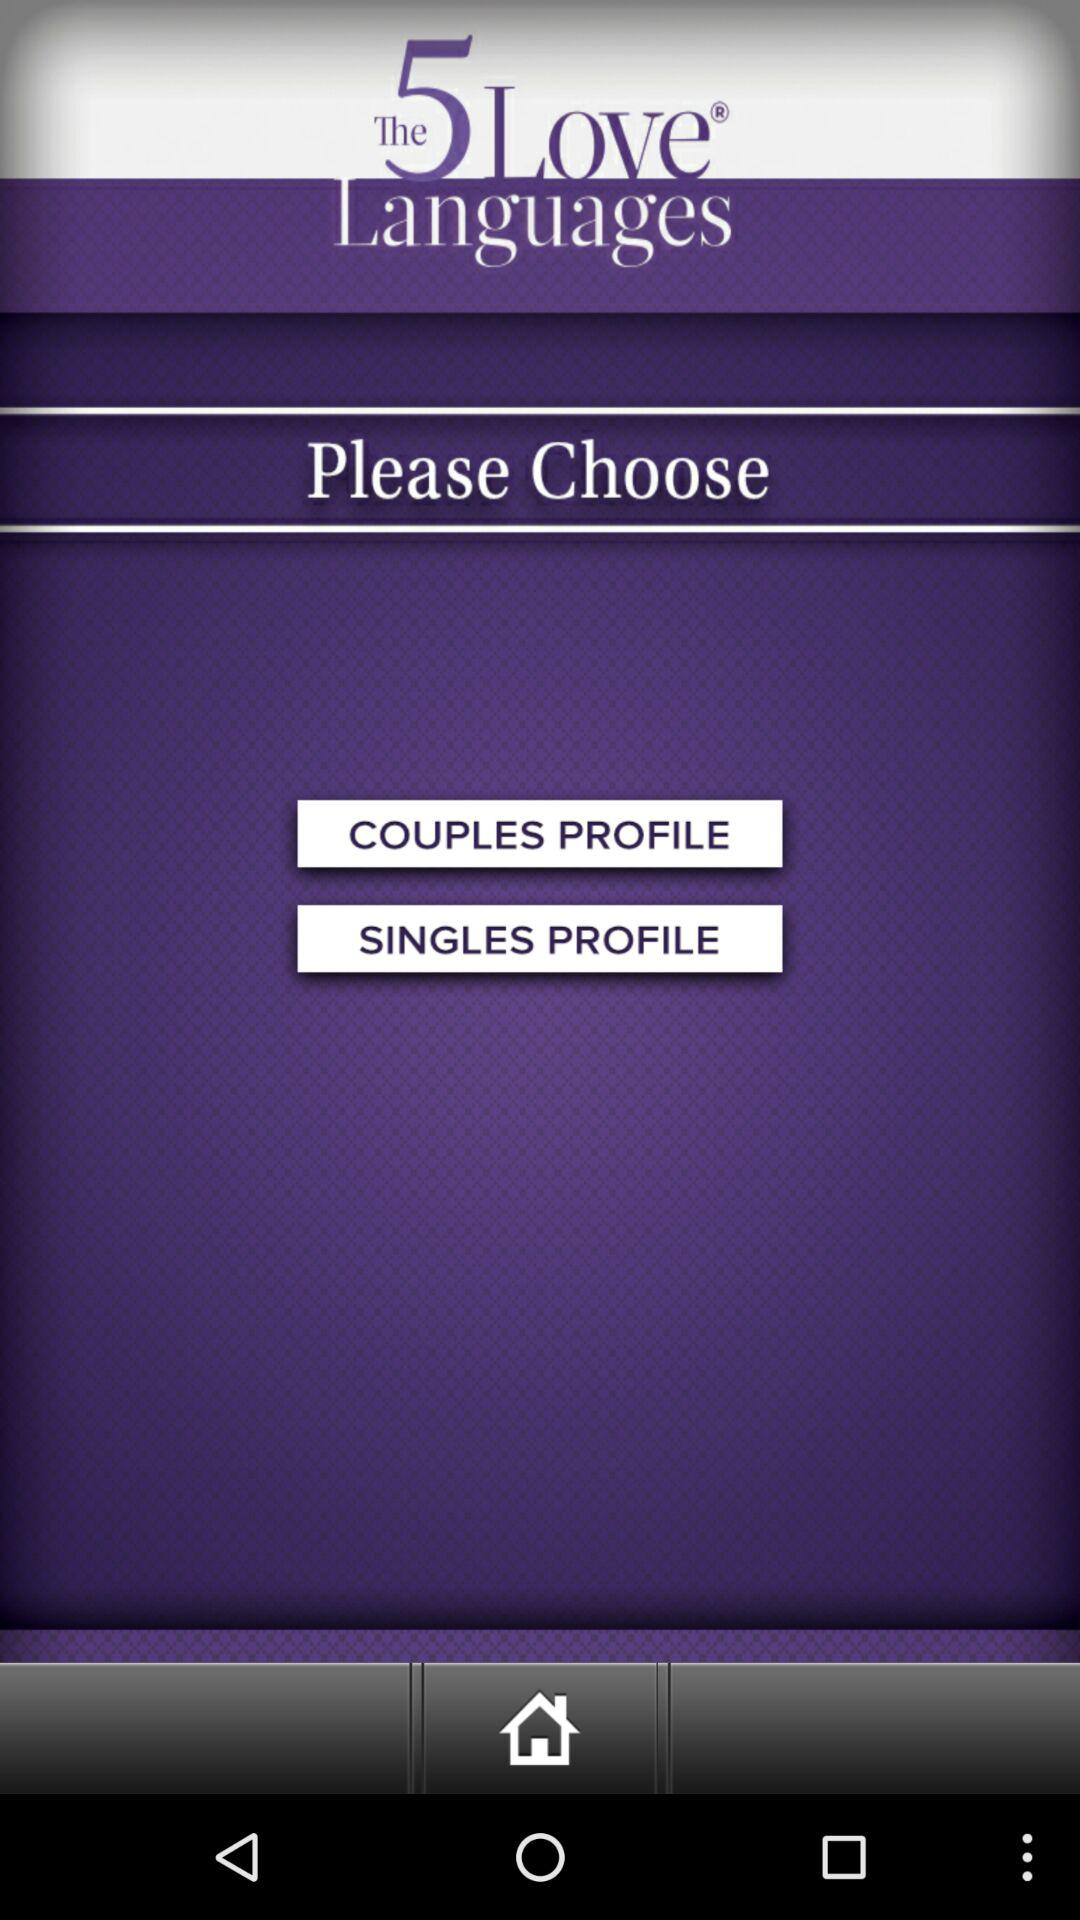What is the application name? The application name is "The 5 Love Languages". 